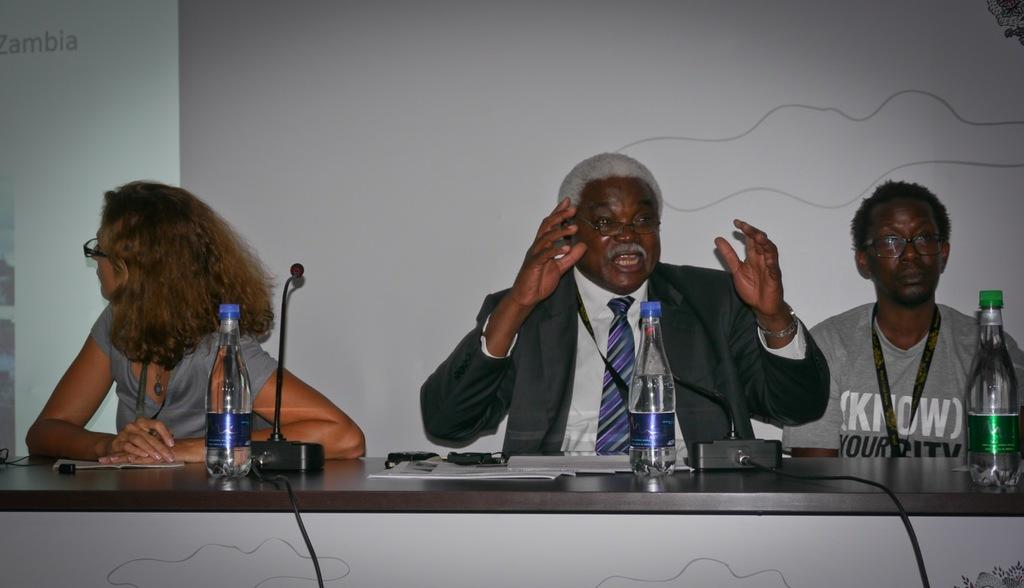What are the people in the image doing? The people in the image are sitting in front of a table. What objects can be seen on the table? There are bottles and papers on the table. What is visible in the background of the image? There is a screen in the background. How many rabbits can be seen hopping around on the table in the image? There are no rabbits present in the image; the table contains bottles and papers. 